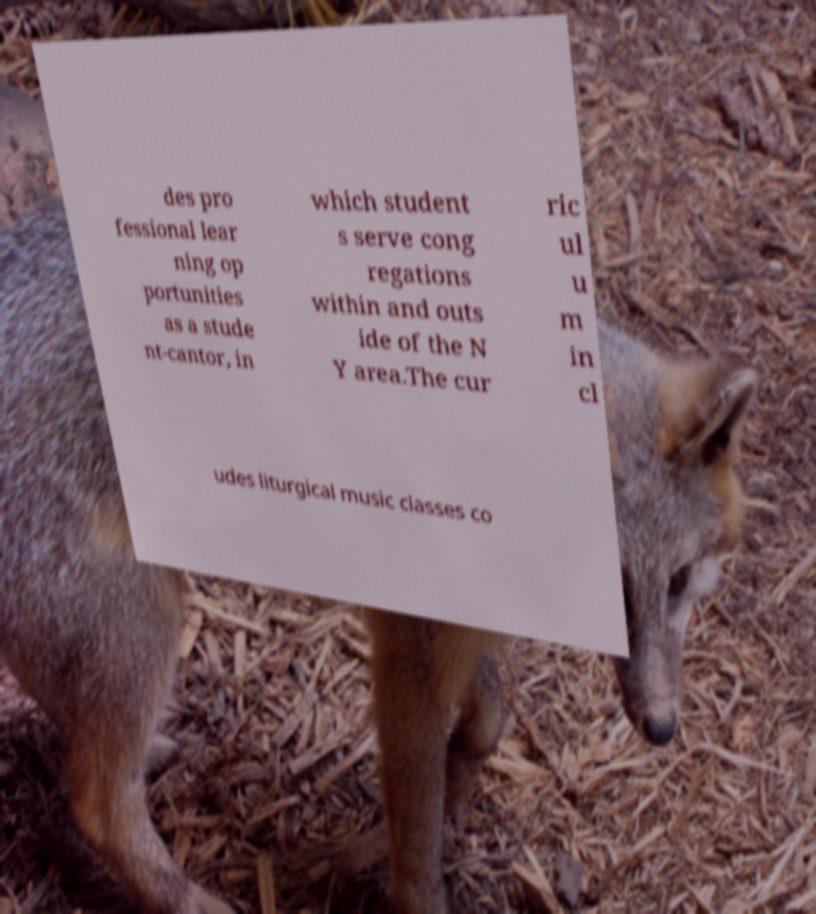I need the written content from this picture converted into text. Can you do that? des pro fessional lear ning op portunities as a stude nt-cantor, in which student s serve cong regations within and outs ide of the N Y area.The cur ric ul u m in cl udes liturgical music classes co 